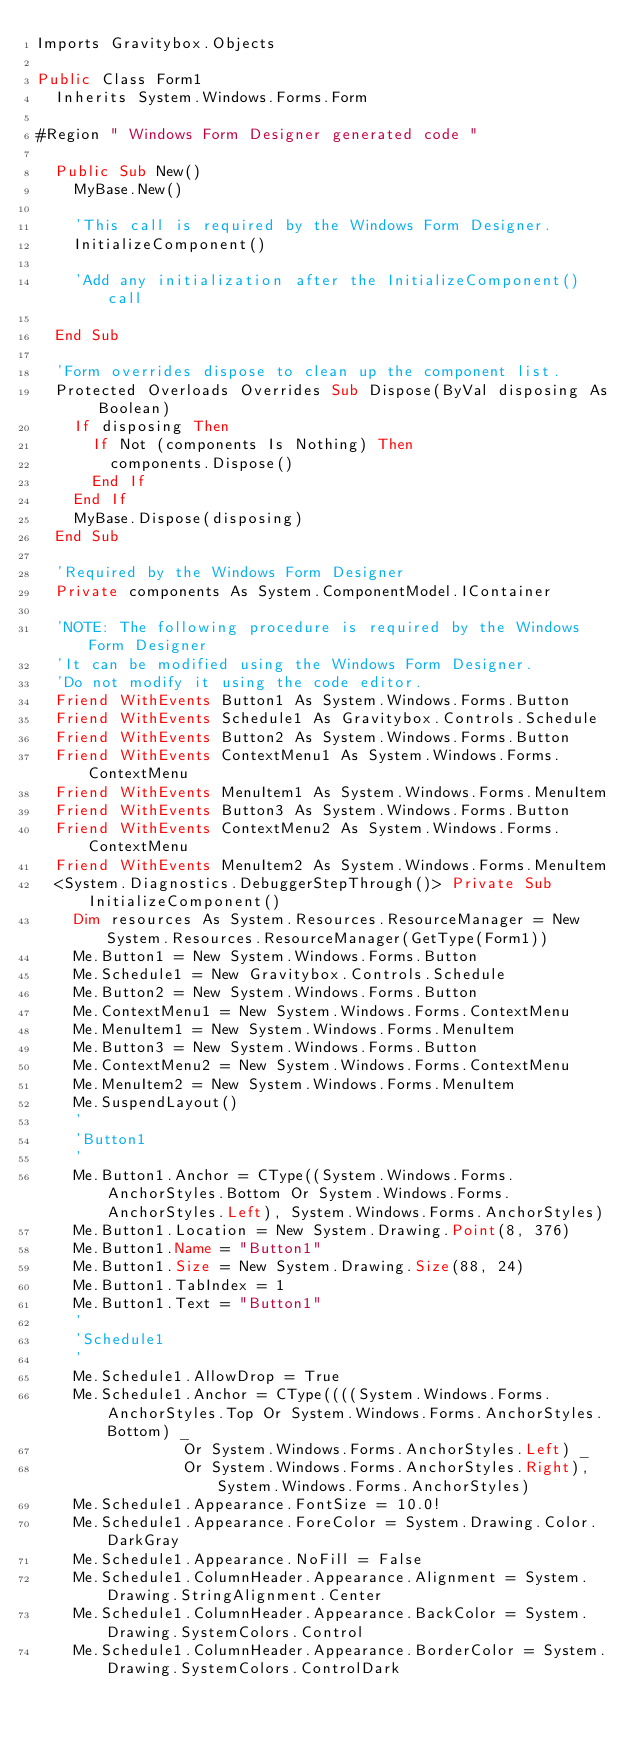Convert code to text. <code><loc_0><loc_0><loc_500><loc_500><_VisualBasic_>Imports Gravitybox.Objects

Public Class Form1
  Inherits System.Windows.Forms.Form

#Region " Windows Form Designer generated code "

  Public Sub New()
    MyBase.New()

    'This call is required by the Windows Form Designer.
    InitializeComponent()

    'Add any initialization after the InitializeComponent() call

  End Sub

  'Form overrides dispose to clean up the component list.
  Protected Overloads Overrides Sub Dispose(ByVal disposing As Boolean)
    If disposing Then
      If Not (components Is Nothing) Then
        components.Dispose()
      End If
    End If
    MyBase.Dispose(disposing)
  End Sub

  'Required by the Windows Form Designer
  Private components As System.ComponentModel.IContainer

  'NOTE: The following procedure is required by the Windows Form Designer
  'It can be modified using the Windows Form Designer.  
  'Do not modify it using the code editor.
  Friend WithEvents Button1 As System.Windows.Forms.Button
  Friend WithEvents Schedule1 As Gravitybox.Controls.Schedule
	Friend WithEvents Button2 As System.Windows.Forms.Button
  Friend WithEvents ContextMenu1 As System.Windows.Forms.ContextMenu
  Friend WithEvents MenuItem1 As System.Windows.Forms.MenuItem
	Friend WithEvents Button3 As System.Windows.Forms.Button
  Friend WithEvents ContextMenu2 As System.Windows.Forms.ContextMenu
  Friend WithEvents MenuItem2 As System.Windows.Forms.MenuItem
  <System.Diagnostics.DebuggerStepThrough()> Private Sub InitializeComponent()
		Dim resources As System.Resources.ResourceManager = New System.Resources.ResourceManager(GetType(Form1))
		Me.Button1 = New System.Windows.Forms.Button
		Me.Schedule1 = New Gravitybox.Controls.Schedule
		Me.Button2 = New System.Windows.Forms.Button
		Me.ContextMenu1 = New System.Windows.Forms.ContextMenu
		Me.MenuItem1 = New System.Windows.Forms.MenuItem
		Me.Button3 = New System.Windows.Forms.Button
		Me.ContextMenu2 = New System.Windows.Forms.ContextMenu
		Me.MenuItem2 = New System.Windows.Forms.MenuItem
		Me.SuspendLayout()
		'
		'Button1
		'
		Me.Button1.Anchor = CType((System.Windows.Forms.AnchorStyles.Bottom Or System.Windows.Forms.AnchorStyles.Left), System.Windows.Forms.AnchorStyles)
		Me.Button1.Location = New System.Drawing.Point(8, 376)
		Me.Button1.Name = "Button1"
		Me.Button1.Size = New System.Drawing.Size(88, 24)
		Me.Button1.TabIndex = 1
		Me.Button1.Text = "Button1"
		'
		'Schedule1
		'
		Me.Schedule1.AllowDrop = True
		Me.Schedule1.Anchor = CType((((System.Windows.Forms.AnchorStyles.Top Or System.Windows.Forms.AnchorStyles.Bottom) _
								Or System.Windows.Forms.AnchorStyles.Left) _
								Or System.Windows.Forms.AnchorStyles.Right), System.Windows.Forms.AnchorStyles)
		Me.Schedule1.Appearance.FontSize = 10.0!
		Me.Schedule1.Appearance.ForeColor = System.Drawing.Color.DarkGray
		Me.Schedule1.Appearance.NoFill = False
		Me.Schedule1.ColumnHeader.Appearance.Alignment = System.Drawing.StringAlignment.Center
		Me.Schedule1.ColumnHeader.Appearance.BackColor = System.Drawing.SystemColors.Control
		Me.Schedule1.ColumnHeader.Appearance.BorderColor = System.Drawing.SystemColors.ControlDark</code> 